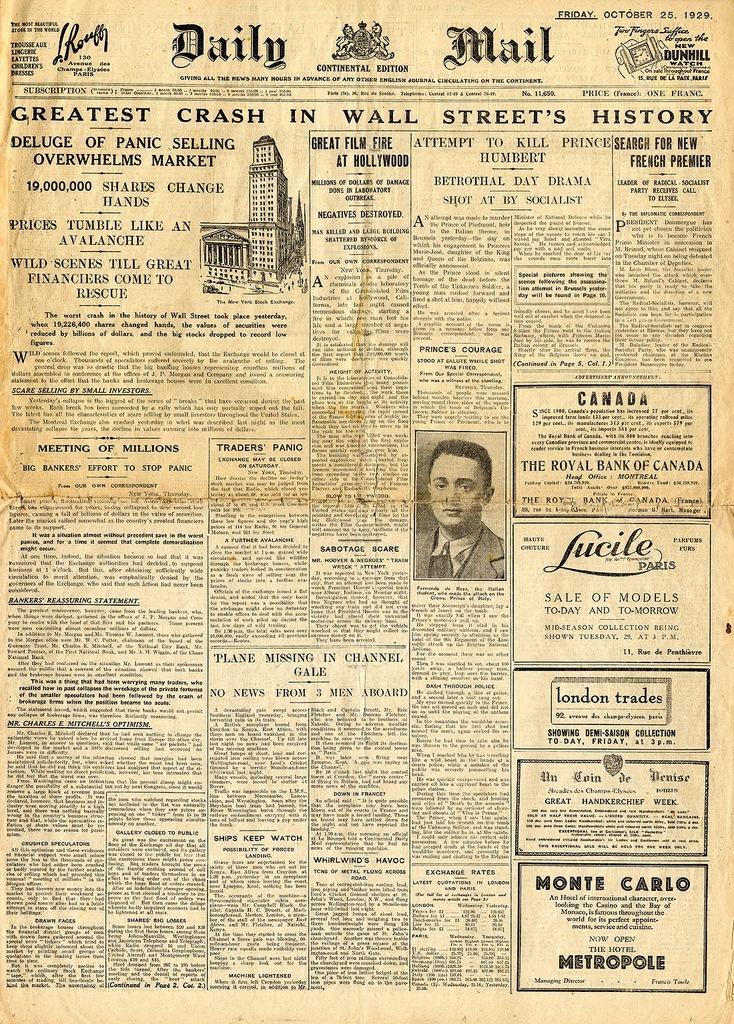Could you give a brief overview of what you see in this image? In this image I can see a paper with the image of the person and drawing of the building and some text. 